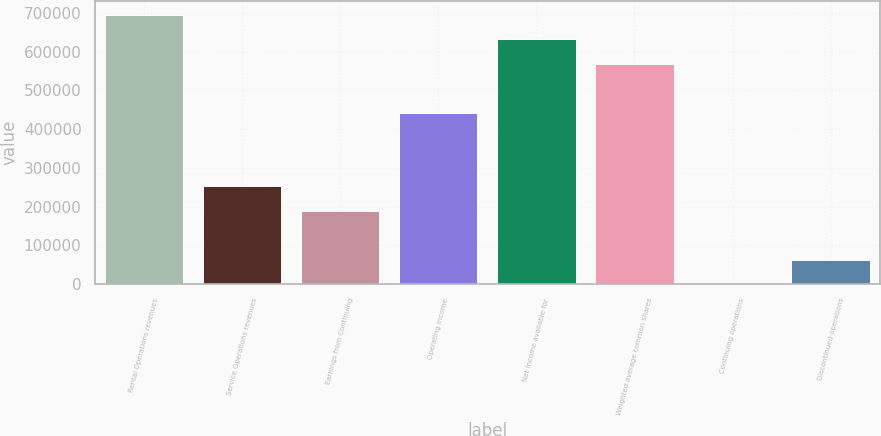<chart> <loc_0><loc_0><loc_500><loc_500><bar_chart><fcel>Rental Operations revenues<fcel>Service Operations revenues<fcel>Earnings from Continuing<fcel>Operating income<fcel>Net income available for<fcel>Weighted average common shares<fcel>Continuing operations<fcel>Discontinued operations<nl><fcel>694772<fcel>252645<fcel>189484<fcel>442128<fcel>631611<fcel>568450<fcel>0.61<fcel>63161.7<nl></chart> 